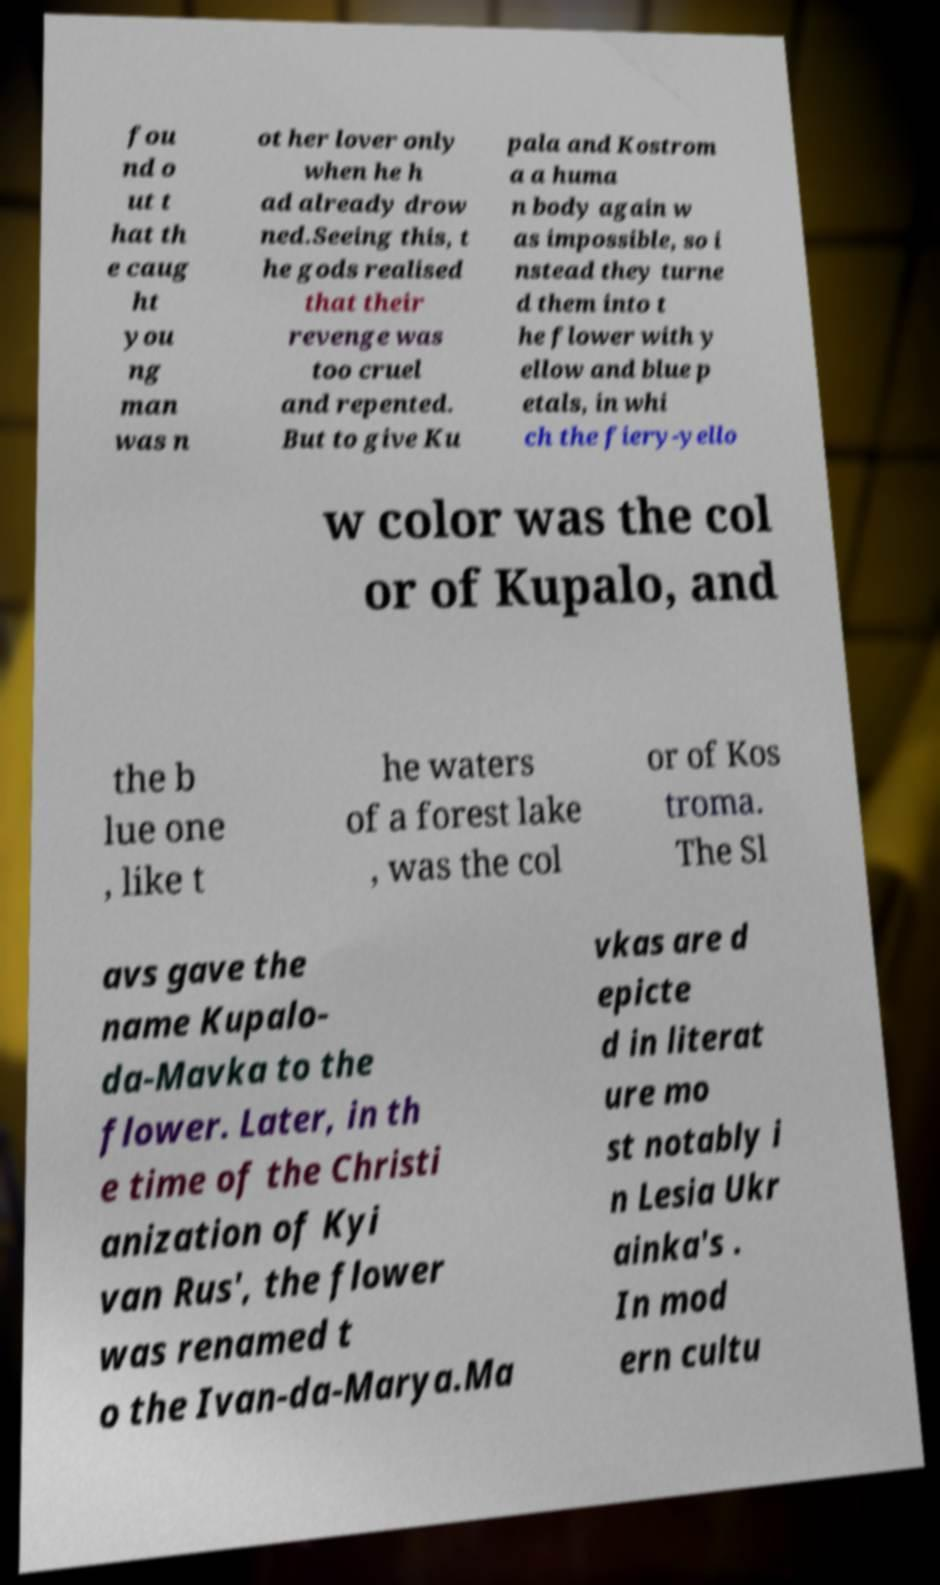Could you extract and type out the text from this image? fou nd o ut t hat th e caug ht you ng man was n ot her lover only when he h ad already drow ned.Seeing this, t he gods realised that their revenge was too cruel and repented. But to give Ku pala and Kostrom a a huma n body again w as impossible, so i nstead they turne d them into t he flower with y ellow and blue p etals, in whi ch the fiery-yello w color was the col or of Kupalo, and the b lue one , like t he waters of a forest lake , was the col or of Kos troma. The Sl avs gave the name Kupalo- da-Mavka to the flower. Later, in th e time of the Christi anization of Kyi van Rus', the flower was renamed t o the Ivan-da-Marya.Ma vkas are d epicte d in literat ure mo st notably i n Lesia Ukr ainka's . In mod ern cultu 